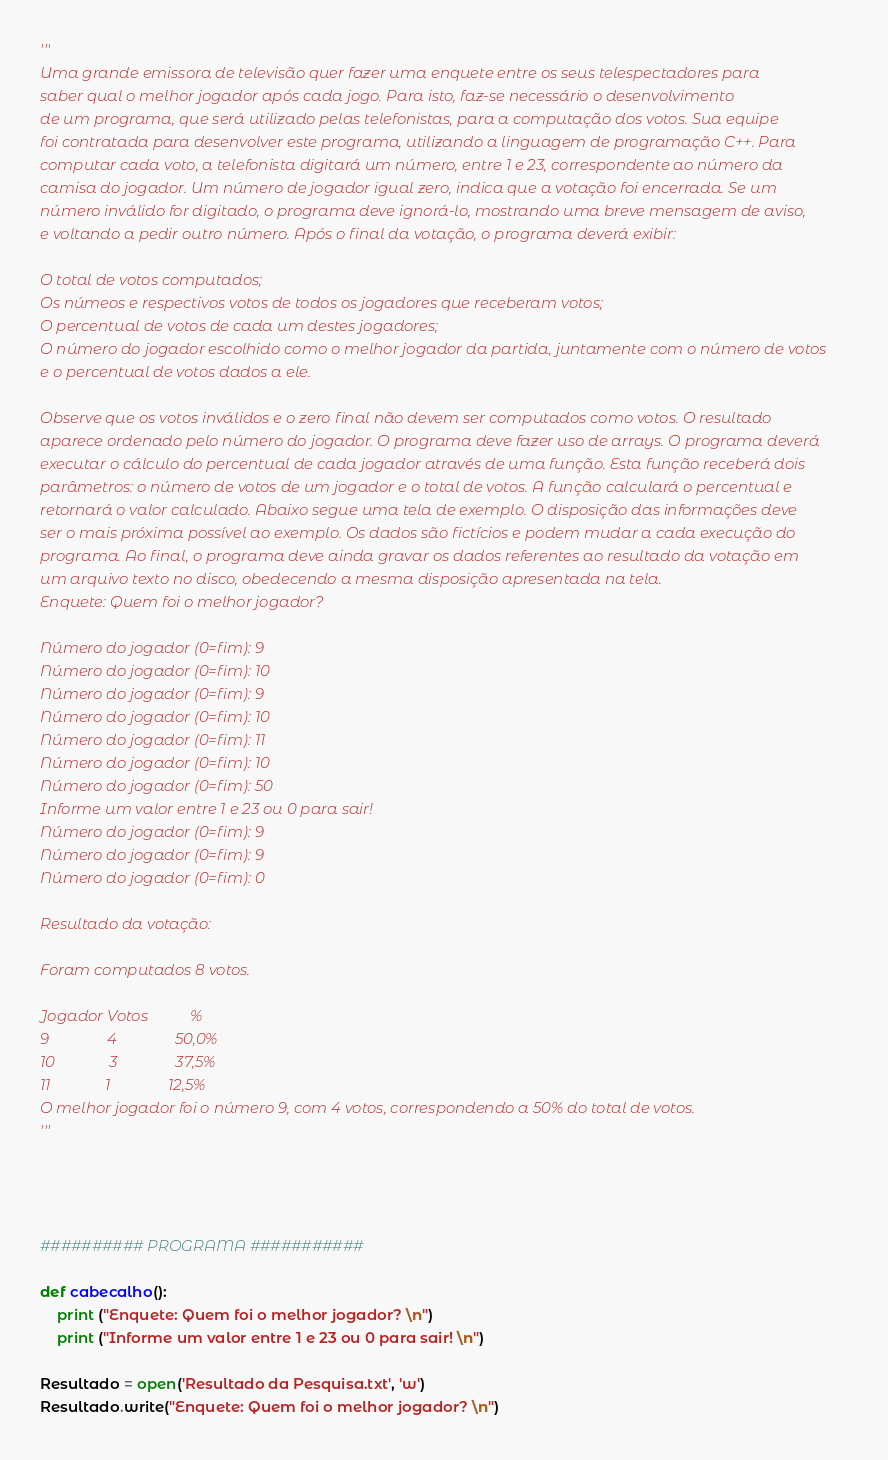<code> <loc_0><loc_0><loc_500><loc_500><_Python_>'''
Uma grande emissora de televisão quer fazer uma enquete entre os seus telespectadores para
saber qual o melhor jogador após cada jogo. Para isto, faz-se necessário o desenvolvimento
de um programa, que será utilizado pelas telefonistas, para a computação dos votos. Sua equipe
foi contratada para desenvolver este programa, utilizando a linguagem de programação C++. Para
computar cada voto, a telefonista digitará um número, entre 1 e 23, correspondente ao número da
camisa do jogador. Um número de jogador igual zero, indica que a votação foi encerrada. Se um
número inválido for digitado, o programa deve ignorá-lo, mostrando uma breve mensagem de aviso,
e voltando a pedir outro número. Após o final da votação, o programa deverá exibir:
    
O total de votos computados;
Os númeos e respectivos votos de todos os jogadores que receberam votos;
O percentual de votos de cada um destes jogadores;
O número do jogador escolhido como o melhor jogador da partida, juntamente com o número de votos
e o percentual de votos dados a ele.

Observe que os votos inválidos e o zero final não devem ser computados como votos. O resultado
aparece ordenado pelo número do jogador. O programa deve fazer uso de arrays. O programa deverá
executar o cálculo do percentual de cada jogador através de uma função. Esta função receberá dois
parâmetros: o número de votos de um jogador e o total de votos. A função calculará o percentual e
retornará o valor calculado. Abaixo segue uma tela de exemplo. O disposição das informações deve
ser o mais próxima possível ao exemplo. Os dados são fictícios e podem mudar a cada execução do
programa. Ao final, o programa deve ainda gravar os dados referentes ao resultado da votação em
um arquivo texto no disco, obedecendo a mesma disposição apresentada na tela.
Enquete: Quem foi o melhor jogador?

Número do jogador (0=fim): 9
Número do jogador (0=fim): 10
Número do jogador (0=fim): 9
Número do jogador (0=fim): 10
Número do jogador (0=fim): 11
Número do jogador (0=fim): 10
Número do jogador (0=fim): 50
Informe um valor entre 1 e 23 ou 0 para sair!
Número do jogador (0=fim): 9
Número do jogador (0=fim): 9
Número do jogador (0=fim): 0

Resultado da votação:

Foram computados 8 votos.

Jogador Votos           %
9               4               50,0%
10              3               37,5%
11              1               12,5%
O melhor jogador foi o número 9, com 4 votos, correspondendo a 50% do total de votos.
'''




########## PROGRAMA ###########

def cabecalho():
    print ("Enquete: Quem foi o melhor jogador? \n")
    print ("Informe um valor entre 1 e 23 ou 0 para sair! \n")

Resultado = open('Resultado da Pesquisa.txt', 'w')
Resultado.write("Enquete: Quem foi o melhor jogador? \n")</code> 